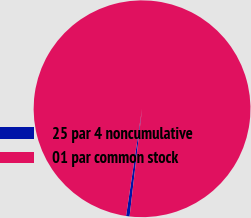Convert chart to OTSL. <chart><loc_0><loc_0><loc_500><loc_500><pie_chart><fcel>25 par 4 noncumulative<fcel>01 par common stock<nl><fcel>0.52%<fcel>99.48%<nl></chart> 